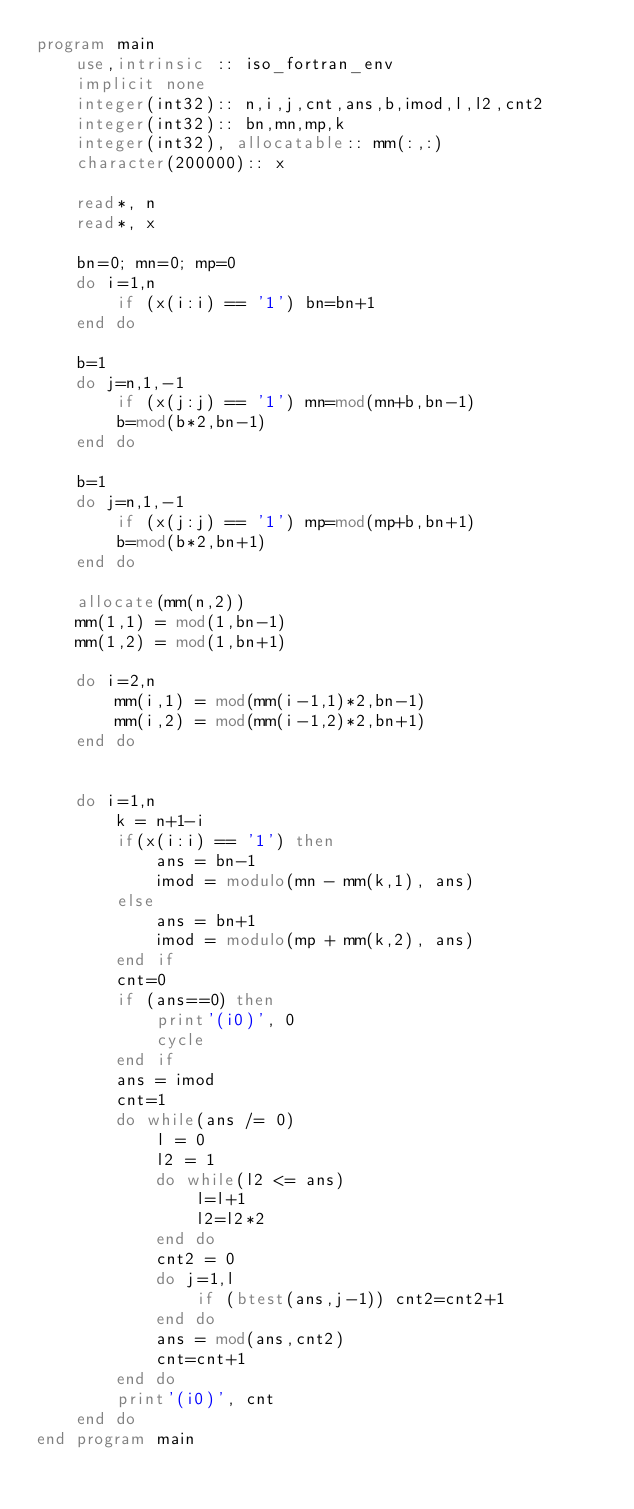<code> <loc_0><loc_0><loc_500><loc_500><_FORTRAN_>program main
    use,intrinsic :: iso_fortran_env
    implicit none
    integer(int32):: n,i,j,cnt,ans,b,imod,l,l2,cnt2
    integer(int32):: bn,mn,mp,k
    integer(int32), allocatable:: mm(:,:)
    character(200000):: x

    read*, n
    read*, x

    bn=0; mn=0; mp=0
    do i=1,n
        if (x(i:i) == '1') bn=bn+1
    end do

    b=1
    do j=n,1,-1
        if (x(j:j) == '1') mn=mod(mn+b,bn-1)
        b=mod(b*2,bn-1)
    end do

    b=1
    do j=n,1,-1
        if (x(j:j) == '1') mp=mod(mp+b,bn+1)
        b=mod(b*2,bn+1)
    end do

    allocate(mm(n,2))
    mm(1,1) = mod(1,bn-1)
    mm(1,2) = mod(1,bn+1)

    do i=2,n
        mm(i,1) = mod(mm(i-1,1)*2,bn-1)
        mm(i,2) = mod(mm(i-1,2)*2,bn+1)
    end do


    do i=1,n
        k = n+1-i
        if(x(i:i) == '1') then
            ans = bn-1
            imod = modulo(mn - mm(k,1), ans)
        else
            ans = bn+1
            imod = modulo(mp + mm(k,2), ans)
        end if
        cnt=0
        if (ans==0) then
            print'(i0)', 0
            cycle
        end if
        ans = imod
        cnt=1
        do while(ans /= 0)
            l = 0
            l2 = 1
            do while(l2 <= ans)
                l=l+1
                l2=l2*2
            end do
            cnt2 = 0
            do j=1,l
                if (btest(ans,j-1)) cnt2=cnt2+1
            end do
            ans = mod(ans,cnt2)
            cnt=cnt+1
        end do
        print'(i0)', cnt
    end do
end program main</code> 